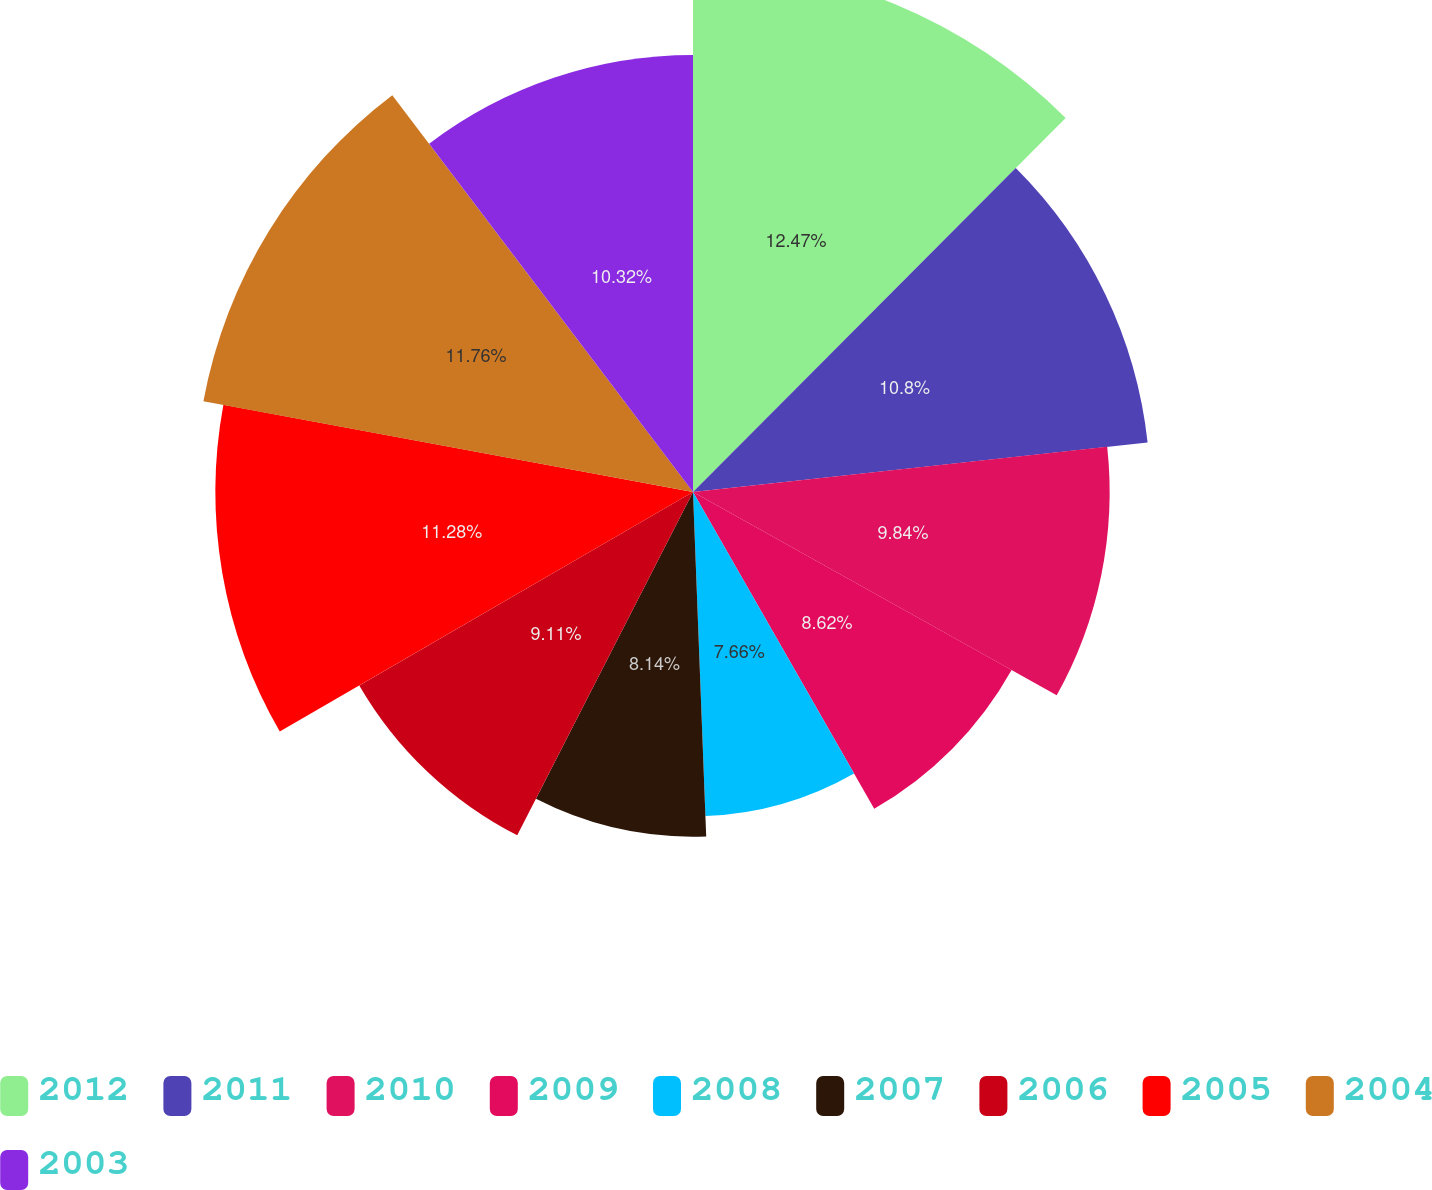Convert chart to OTSL. <chart><loc_0><loc_0><loc_500><loc_500><pie_chart><fcel>2012<fcel>2011<fcel>2010<fcel>2009<fcel>2008<fcel>2007<fcel>2006<fcel>2005<fcel>2004<fcel>2003<nl><fcel>12.47%<fcel>10.8%<fcel>9.84%<fcel>8.62%<fcel>7.66%<fcel>8.14%<fcel>9.11%<fcel>11.28%<fcel>11.76%<fcel>10.32%<nl></chart> 